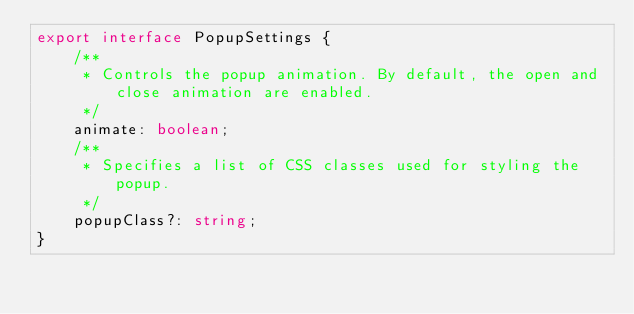<code> <loc_0><loc_0><loc_500><loc_500><_TypeScript_>export interface PopupSettings {
    /**
     * Controls the popup animation. By default, the open and close animation are enabled.
     */
    animate: boolean;
    /**
     * Specifies a list of CSS classes used for styling the popup.
     */
    popupClass?: string;
}
</code> 